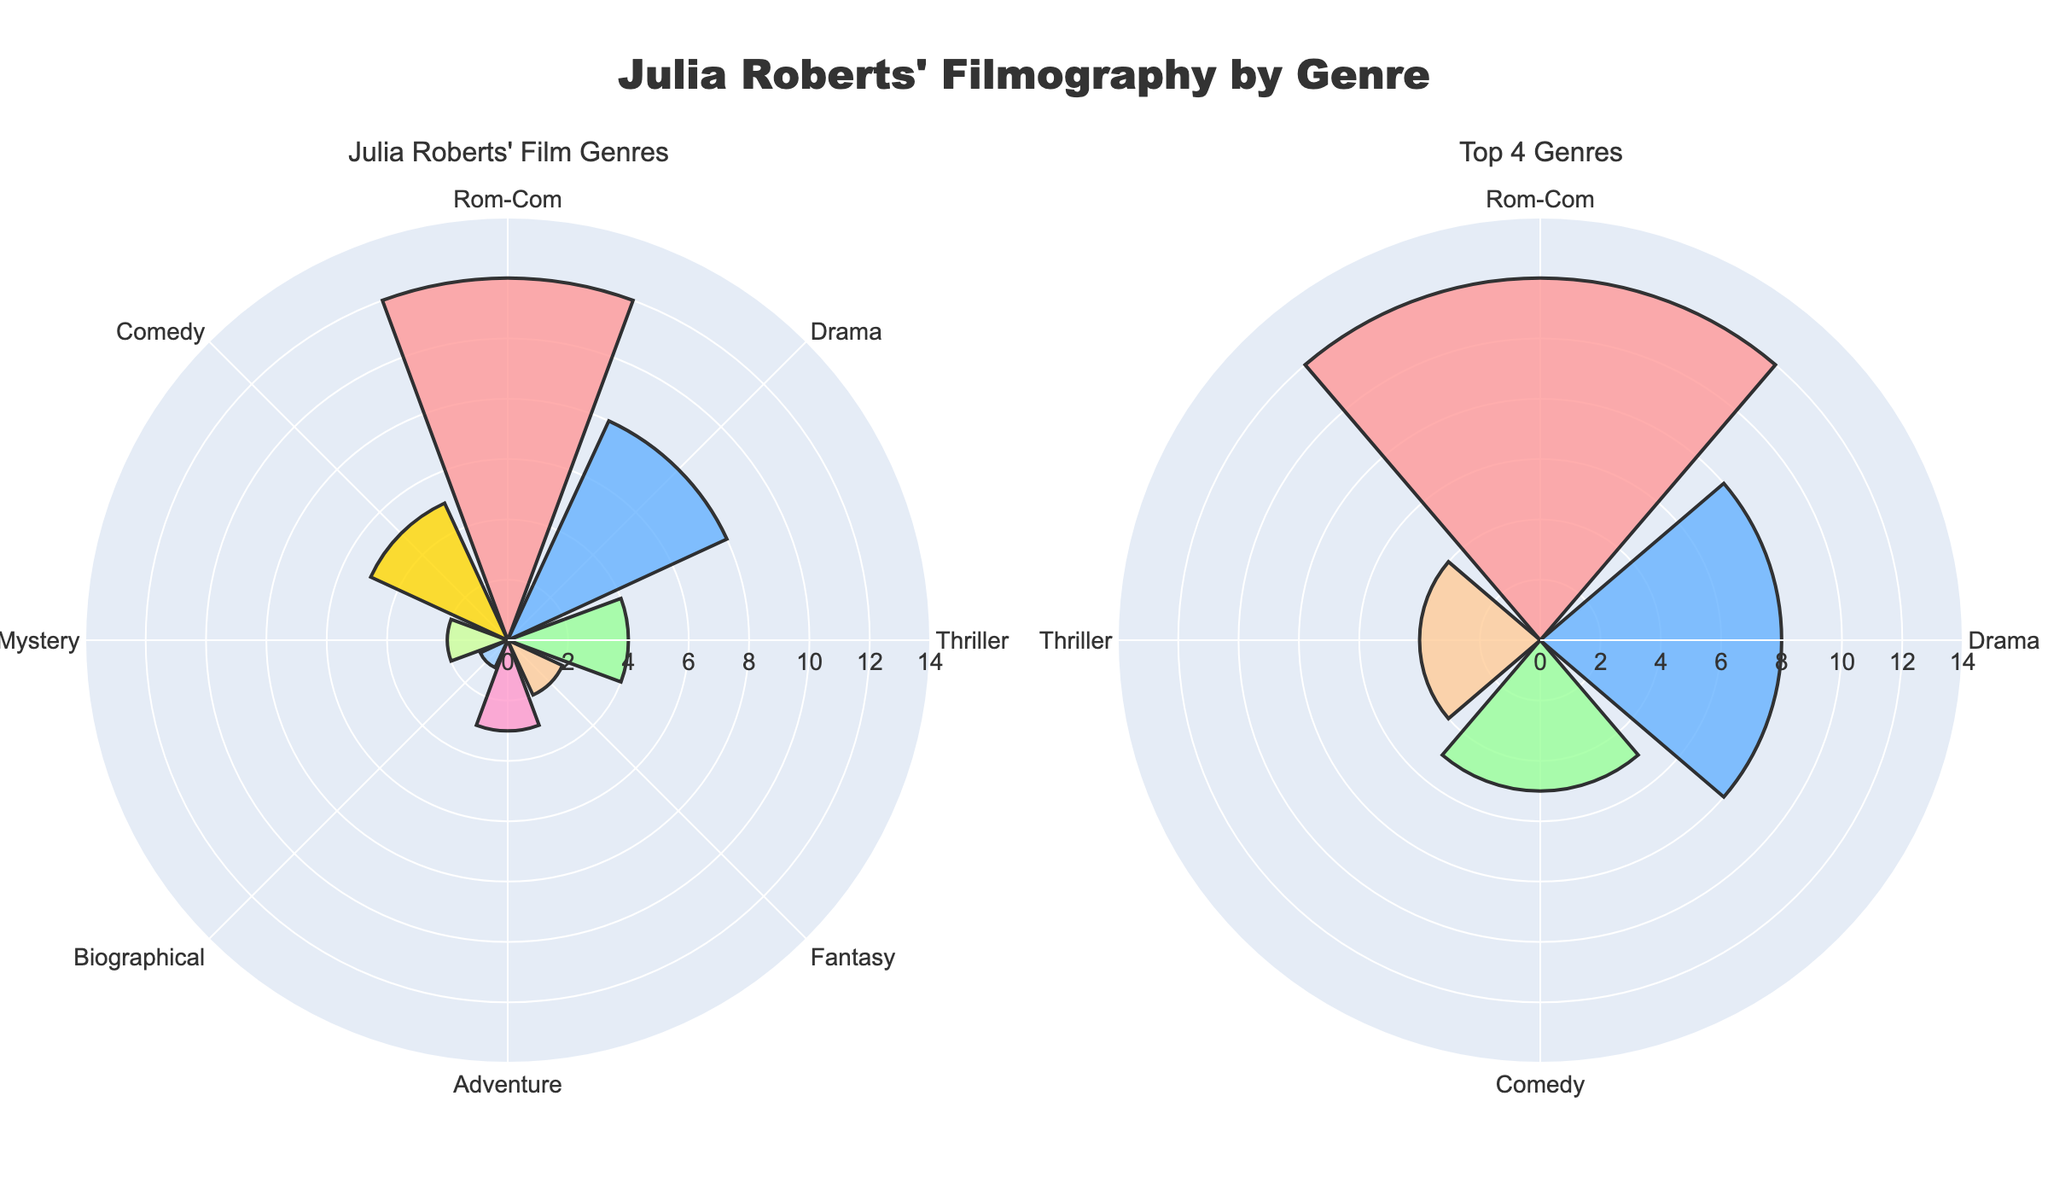What's the most frequent film genre Julia Roberts starred in? The genre with the highest bar on the first subplot is Rom-Com.
Answer: Rom-Com How many Rom-Com films did Julia Roberts act in? The length of the bar corresponding to Rom-Com in the first subplot is 12.
Answer: 12 Which four genres are highlighted in the "Top 4 Genres" subplot? The second subplot focuses on the genres Rom-Com, Drama, Comedy, and Thriller, which are the largest in the first subplot.
Answer: Rom-Com, Drama, Comedy, Thriller What's the total number of films Julia Roberts acted in across all genres? The total is the sum of the number of films in each genre: 12 + 8 + 4 + 2 + 3 + 1 + 2 + 5 = 37.
Answer: 37 How many more Rom-Com films did Julia Roberts act in compared to Thriller films? The number of Rom-Com films is 12, and the number of Thriller films is 4. So, the difference is 12 - 4 = 8.
Answer: 8 Between Drama and Comedy genres, which one has more films? Looking at the bars in the first subplot, Drama has 8 films while Comedy has 5 films.
Answer: Drama What's the average number of films across all genres? Total number of films is 37. There are 8 genres. So, the average is 37 / 8 = 4.625.
Answer: 4.625 If Julia Roberts had acted in 3 more Mystery films, how would this impact the Top 4 Genres subplot? Adding 3 more Mystery films would make the total 2 + 3 = 5 for Mystery, which ties with Comedy. New top 4 now would be Rom-Com, Drama, Comedy, and Mystery.
Answer: Rom-Com, Drama, Comedy, Mystery Identify the color used for the Adventure genre in the first subplot. The color for the Adventure genre bar is golden yellow.
Answer: Golden yellow What percentage of Julia Roberts' films are Rom-Coms out of the total 37 films? The number of Rom-Com films is 12. The percentage is (12 / 37) * 100 ≈ 32.43%.
Answer: 32.43% 